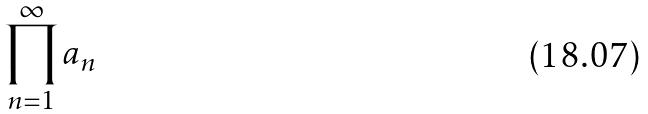Convert formula to latex. <formula><loc_0><loc_0><loc_500><loc_500>\prod _ { n = 1 } ^ { \infty } a _ { n }</formula> 